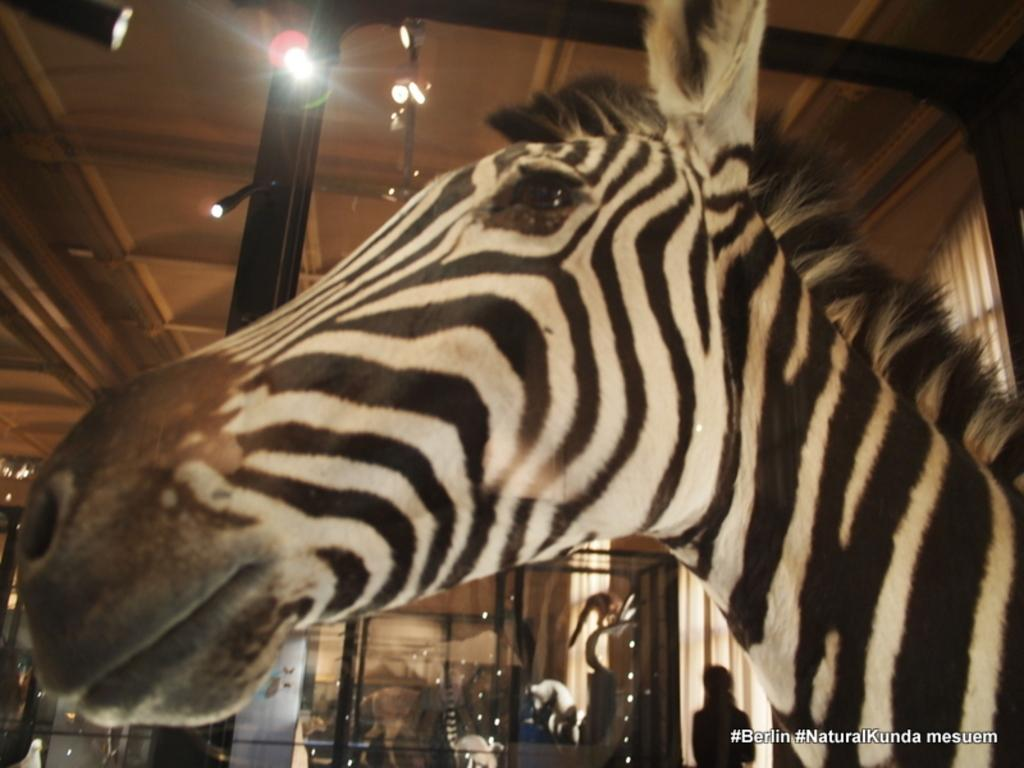What animal is the main subject of the image? There is a zebra in the image. What else can be seen in the image besides the zebra? There is text in the image, and in the background, there are lights on a rooftop, metal rods, animals, a fence, and a person. Can you describe the setting of the image? The image may have been taken in a hall. What type of volleyball net can be seen in the image? There is no volleyball net present in the image. How does the beam support the structure in the image? There is no beam present in the image. 